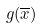Convert formula to latex. <formula><loc_0><loc_0><loc_500><loc_500>g ( \overline { x } )</formula> 